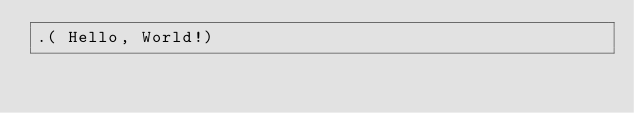Convert code to text. <code><loc_0><loc_0><loc_500><loc_500><_Forth_>.( Hello, World!)
</code> 